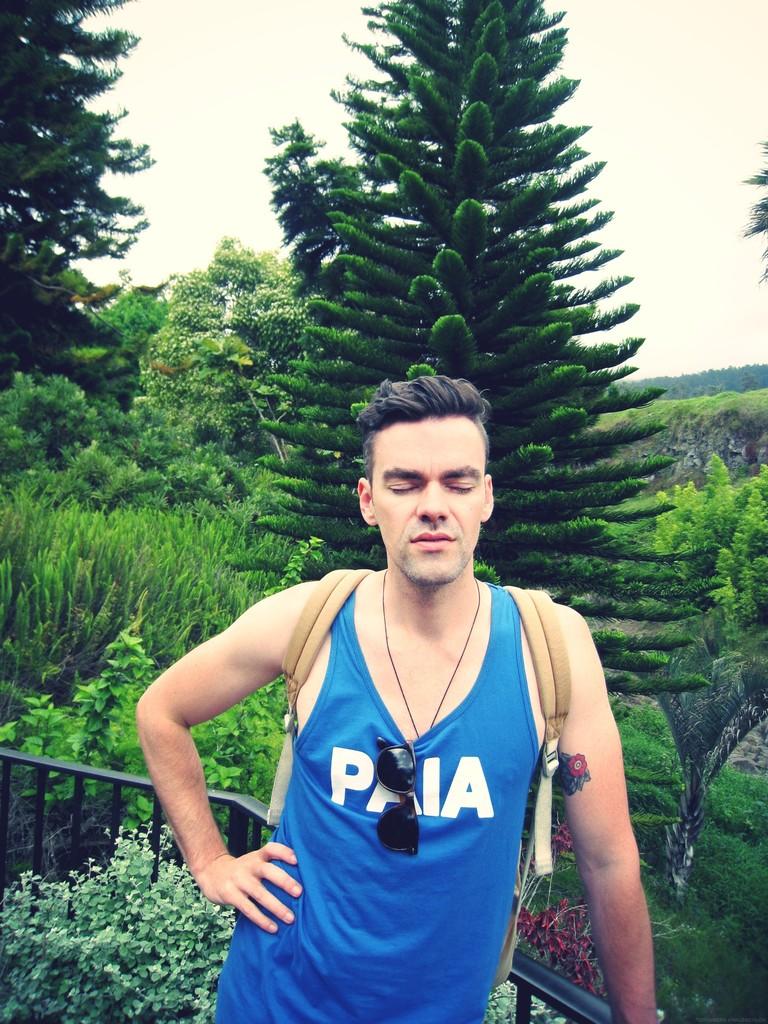What does it say on his shirt?
Ensure brevity in your answer.  Paia. 